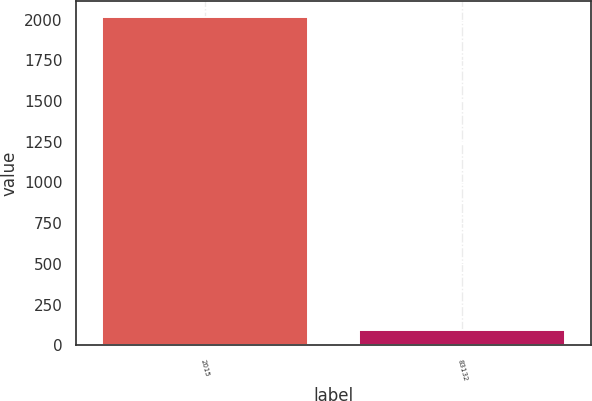Convert chart to OTSL. <chart><loc_0><loc_0><loc_500><loc_500><bar_chart><fcel>2015<fcel>83132<nl><fcel>2014<fcel>94<nl></chart> 